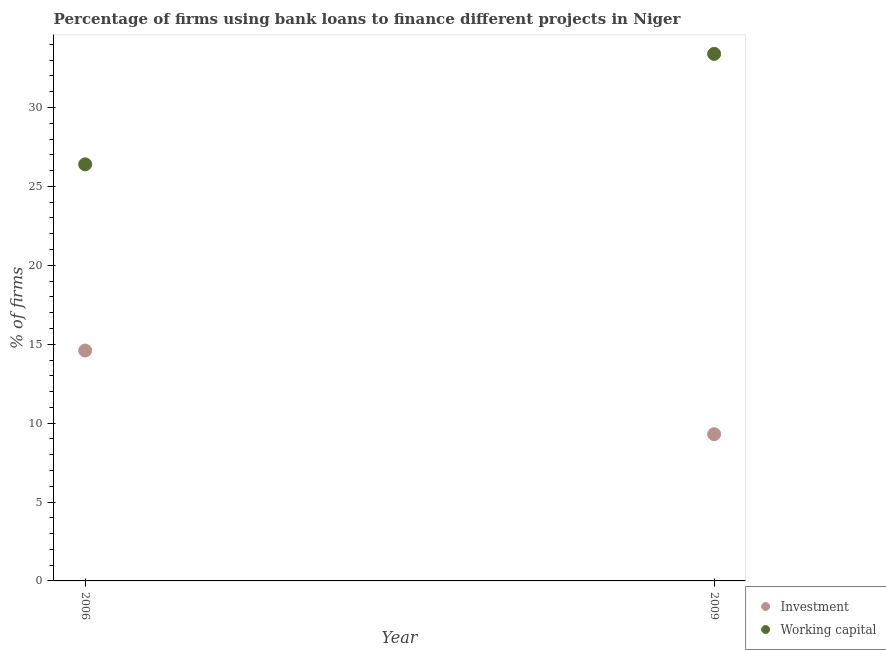Is the number of dotlines equal to the number of legend labels?
Your answer should be compact. Yes. What is the percentage of firms using banks to finance working capital in 2006?
Provide a succinct answer. 26.4. Across all years, what is the minimum percentage of firms using banks to finance working capital?
Ensure brevity in your answer.  26.4. What is the total percentage of firms using banks to finance working capital in the graph?
Ensure brevity in your answer.  59.8. What is the difference between the percentage of firms using banks to finance investment in 2006 and that in 2009?
Provide a succinct answer. 5.3. What is the difference between the percentage of firms using banks to finance investment in 2006 and the percentage of firms using banks to finance working capital in 2009?
Ensure brevity in your answer.  -18.8. What is the average percentage of firms using banks to finance investment per year?
Your answer should be very brief. 11.95. In the year 2006, what is the difference between the percentage of firms using banks to finance investment and percentage of firms using banks to finance working capital?
Your response must be concise. -11.8. In how many years, is the percentage of firms using banks to finance investment greater than 28 %?
Keep it short and to the point. 0. What is the ratio of the percentage of firms using banks to finance working capital in 2006 to that in 2009?
Give a very brief answer. 0.79. How many dotlines are there?
Provide a short and direct response. 2. How many years are there in the graph?
Keep it short and to the point. 2. Are the values on the major ticks of Y-axis written in scientific E-notation?
Provide a short and direct response. No. Where does the legend appear in the graph?
Your answer should be very brief. Bottom right. How many legend labels are there?
Give a very brief answer. 2. How are the legend labels stacked?
Your answer should be very brief. Vertical. What is the title of the graph?
Keep it short and to the point. Percentage of firms using bank loans to finance different projects in Niger. What is the label or title of the Y-axis?
Give a very brief answer. % of firms. What is the % of firms in Investment in 2006?
Keep it short and to the point. 14.6. What is the % of firms in Working capital in 2006?
Make the answer very short. 26.4. What is the % of firms in Investment in 2009?
Offer a terse response. 9.3. What is the % of firms in Working capital in 2009?
Provide a succinct answer. 33.4. Across all years, what is the maximum % of firms in Investment?
Make the answer very short. 14.6. Across all years, what is the maximum % of firms in Working capital?
Your response must be concise. 33.4. Across all years, what is the minimum % of firms in Working capital?
Offer a terse response. 26.4. What is the total % of firms of Investment in the graph?
Keep it short and to the point. 23.9. What is the total % of firms in Working capital in the graph?
Provide a succinct answer. 59.8. What is the difference between the % of firms in Investment in 2006 and that in 2009?
Offer a terse response. 5.3. What is the difference between the % of firms in Working capital in 2006 and that in 2009?
Keep it short and to the point. -7. What is the difference between the % of firms in Investment in 2006 and the % of firms in Working capital in 2009?
Your answer should be compact. -18.8. What is the average % of firms in Investment per year?
Provide a short and direct response. 11.95. What is the average % of firms of Working capital per year?
Offer a very short reply. 29.9. In the year 2009, what is the difference between the % of firms of Investment and % of firms of Working capital?
Keep it short and to the point. -24.1. What is the ratio of the % of firms of Investment in 2006 to that in 2009?
Offer a terse response. 1.57. What is the ratio of the % of firms of Working capital in 2006 to that in 2009?
Keep it short and to the point. 0.79. What is the difference between the highest and the second highest % of firms in Investment?
Offer a very short reply. 5.3. What is the difference between the highest and the lowest % of firms in Working capital?
Provide a short and direct response. 7. 